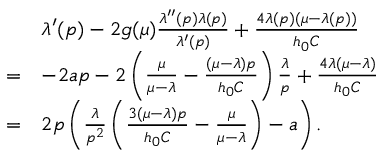Convert formula to latex. <formula><loc_0><loc_0><loc_500><loc_500>\begin{array} { r l } & { \lambda ^ { \prime } ( p ) - 2 g ( \mu ) \frac { \lambda ^ { \prime \prime } ( p ) \lambda ( p ) } { \lambda ^ { \prime } ( p ) } + \frac { 4 \lambda ( p ) ( \mu - \lambda ( p ) ) } { h _ { 0 } C } } \\ { = } & { - 2 a p - 2 \left ( \frac { \mu } { \mu - \lambda } - \frac { ( \mu - \lambda ) p } { h _ { 0 } C } \right ) \frac { \lambda } { p } + \frac { 4 \lambda ( \mu - \lambda ) } { h _ { 0 } C } } \\ { = } & { 2 p \left ( \frac { \lambda } { p ^ { 2 } } \left ( \frac { 3 ( \mu - \lambda ) p } { h _ { 0 } C } - \frac { \mu } { \mu - \lambda } \right ) - a \right ) . } \end{array}</formula> 